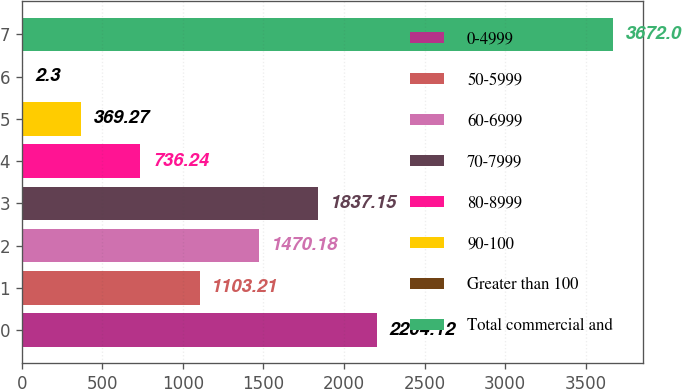Convert chart to OTSL. <chart><loc_0><loc_0><loc_500><loc_500><bar_chart><fcel>0-4999<fcel>50-5999<fcel>60-6999<fcel>70-7999<fcel>80-8999<fcel>90-100<fcel>Greater than 100<fcel>Total commercial and<nl><fcel>2204.12<fcel>1103.21<fcel>1470.18<fcel>1837.15<fcel>736.24<fcel>369.27<fcel>2.3<fcel>3672<nl></chart> 